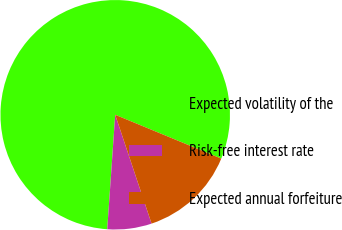<chart> <loc_0><loc_0><loc_500><loc_500><pie_chart><fcel>Expected volatility of the<fcel>Risk-free interest rate<fcel>Expected annual forfeiture<nl><fcel>80.13%<fcel>6.24%<fcel>13.63%<nl></chart> 